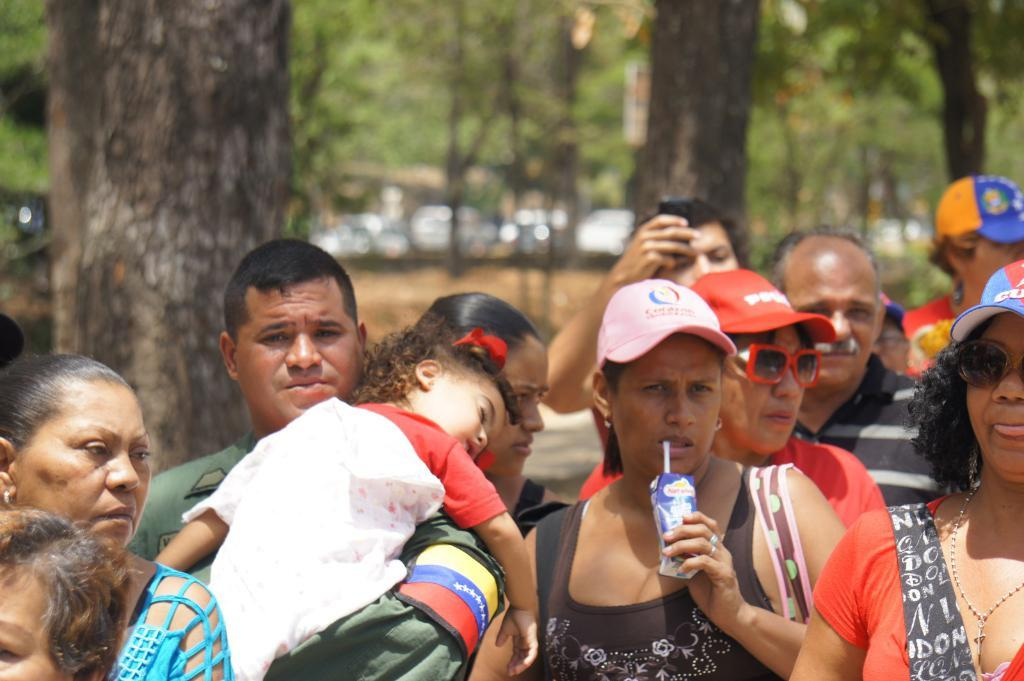How many people are in the image? There are persons in the image, but the exact number is not specified. What can be seen in the background of the image? There are trees and vehicles in the background of the image. What type of steel is visible in the image? There is no steel present in the image. Where is the spot where the person is standing in the image? The facts do not specify a spot where the person is standing, so we cannot determine its location. 